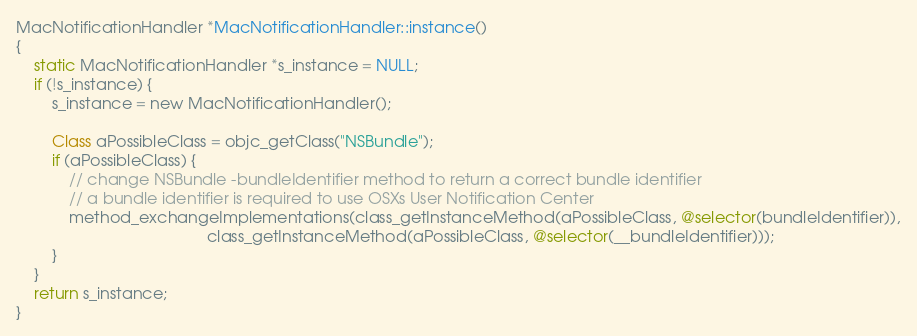Convert code to text. <code><loc_0><loc_0><loc_500><loc_500><_ObjectiveC_>
MacNotificationHandler *MacNotificationHandler::instance()
{
    static MacNotificationHandler *s_instance = NULL;
    if (!s_instance) {
        s_instance = new MacNotificationHandler();
        
        Class aPossibleClass = objc_getClass("NSBundle");
        if (aPossibleClass) {
            // change NSBundle -bundleIdentifier method to return a correct bundle identifier
            // a bundle identifier is required to use OSXs User Notification Center
            method_exchangeImplementations(class_getInstanceMethod(aPossibleClass, @selector(bundleIdentifier)),
                                           class_getInstanceMethod(aPossibleClass, @selector(__bundleIdentifier)));
        }
    }
    return s_instance;
}
</code> 